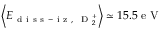<formula> <loc_0><loc_0><loc_500><loc_500>\left \langle E _ { d i s s - i z , D _ { 2 } ^ { + } } \right \rangle \simeq 1 5 . 5 e V</formula> 